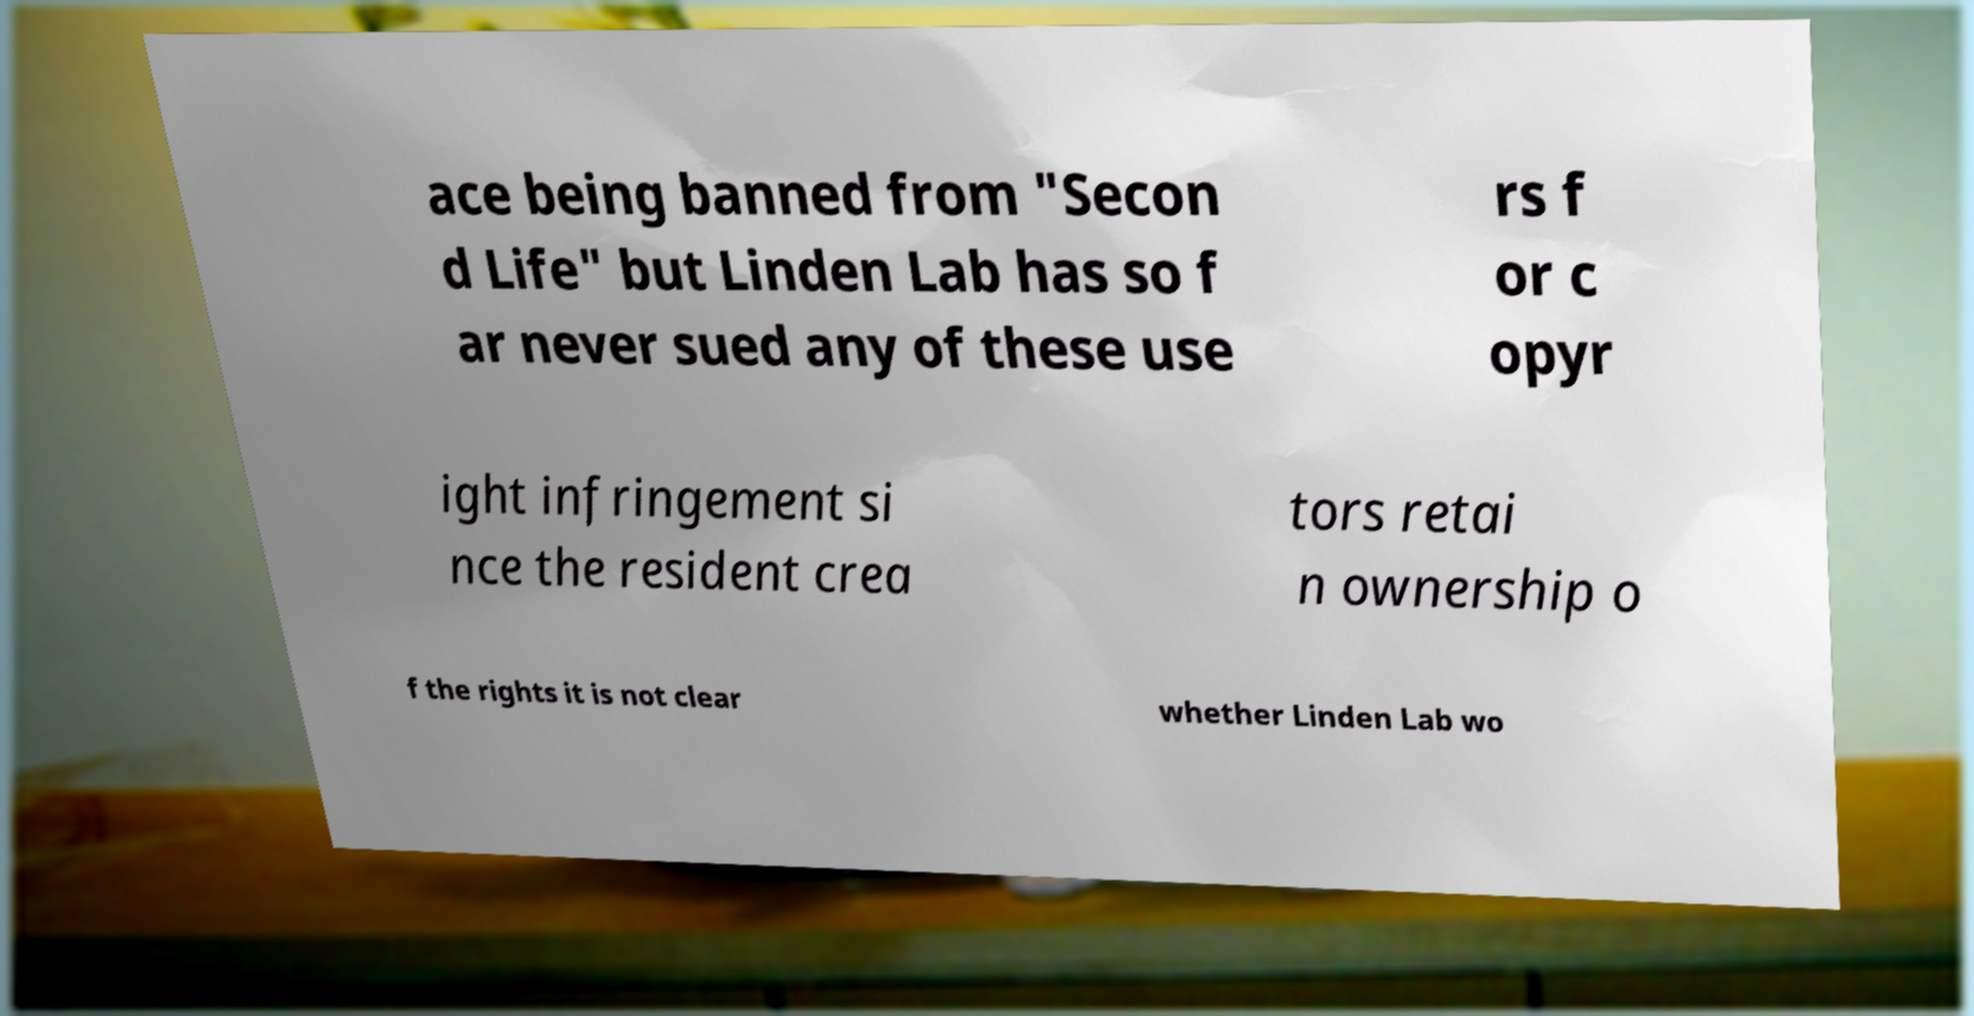What messages or text are displayed in this image? I need them in a readable, typed format. ace being banned from "Secon d Life" but Linden Lab has so f ar never sued any of these use rs f or c opyr ight infringement si nce the resident crea tors retai n ownership o f the rights it is not clear whether Linden Lab wo 